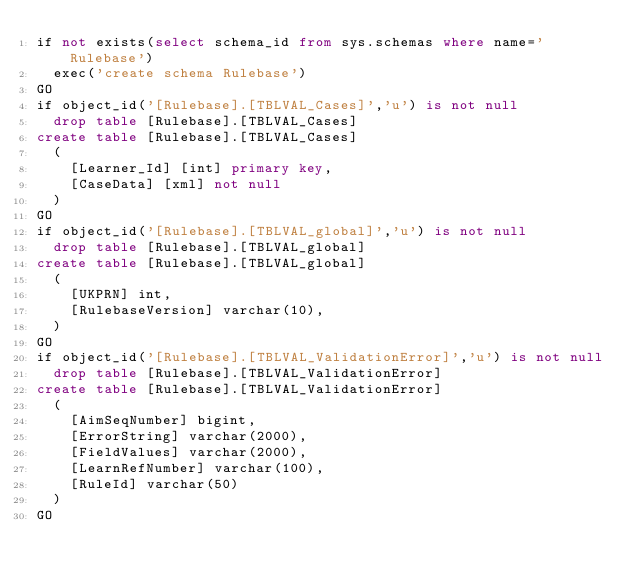Convert code to text. <code><loc_0><loc_0><loc_500><loc_500><_SQL_>if not exists(select schema_id from sys.schemas where name='Rulebase')
	exec('create schema Rulebase')
GO
if object_id('[Rulebase].[TBLVAL_Cases]','u') is not null
	drop table [Rulebase].[TBLVAL_Cases]
create table [Rulebase].[TBLVAL_Cases]
	(
		[Learner_Id] [int] primary key,
		[CaseData] [xml] not null
	)
GO
if object_id('[Rulebase].[TBLVAL_global]','u') is not null
	drop table [Rulebase].[TBLVAL_global]
create table [Rulebase].[TBLVAL_global]
	(
		[UKPRN] int,
		[RulebaseVersion] varchar(10),
	)
GO
if object_id('[Rulebase].[TBLVAL_ValidationError]','u') is not null
	drop table [Rulebase].[TBLVAL_ValidationError]
create table [Rulebase].[TBLVAL_ValidationError]
	(
		[AimSeqNumber] bigint,
		[ErrorString] varchar(2000),
		[FieldValues] varchar(2000),
		[LearnRefNumber] varchar(100),
		[RuleId] varchar(50)
	)
GO
</code> 